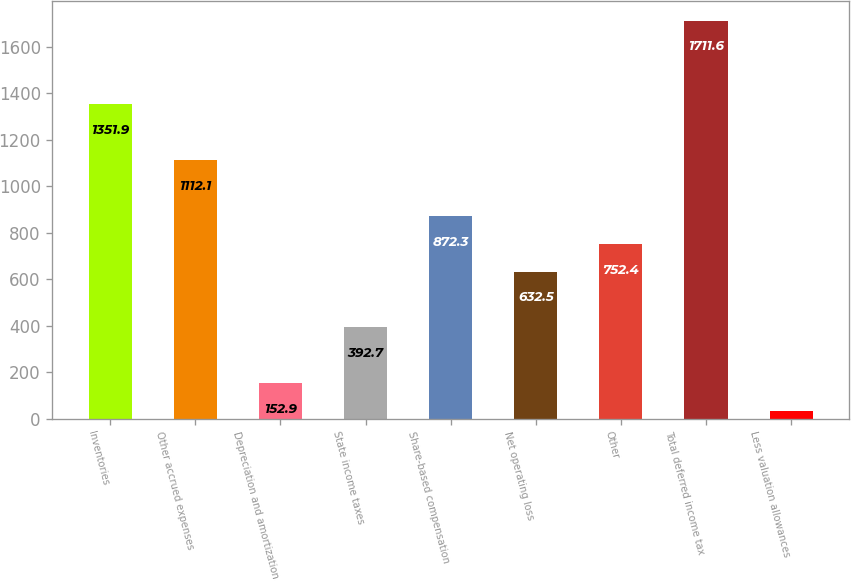<chart> <loc_0><loc_0><loc_500><loc_500><bar_chart><fcel>Inventories<fcel>Other accrued expenses<fcel>Depreciation and amortization<fcel>State income taxes<fcel>Share-based compensation<fcel>Net operating loss<fcel>Other<fcel>Total deferred income tax<fcel>Less valuation allowances<nl><fcel>1351.9<fcel>1112.1<fcel>152.9<fcel>392.7<fcel>872.3<fcel>632.5<fcel>752.4<fcel>1711.6<fcel>33<nl></chart> 